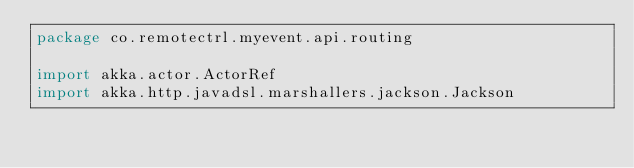Convert code to text. <code><loc_0><loc_0><loc_500><loc_500><_Kotlin_>package co.remotectrl.myevent.api.routing

import akka.actor.ActorRef
import akka.http.javadsl.marshallers.jackson.Jackson</code> 